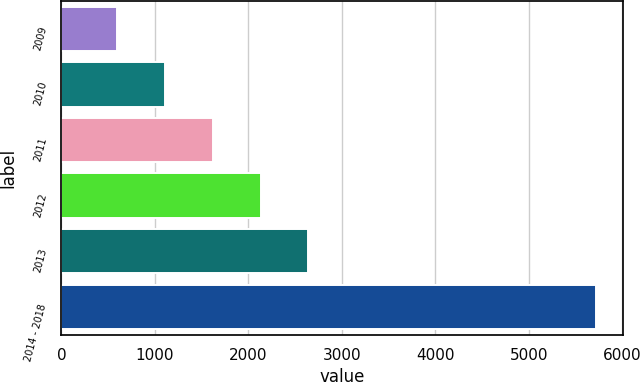Convert chart to OTSL. <chart><loc_0><loc_0><loc_500><loc_500><bar_chart><fcel>2009<fcel>2010<fcel>2011<fcel>2012<fcel>2013<fcel>2014 - 2018<nl><fcel>592<fcel>1104.3<fcel>1616.6<fcel>2128.9<fcel>2641.2<fcel>5715<nl></chart> 